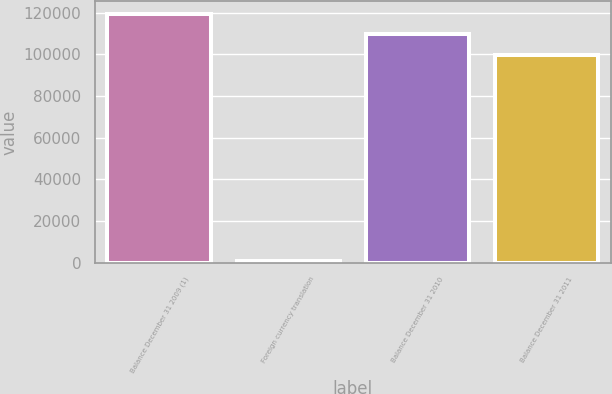<chart> <loc_0><loc_0><loc_500><loc_500><bar_chart><fcel>Balance December 31 2009 (1)<fcel>Foreign currency translation<fcel>Balance December 31 2010<fcel>Balance December 31 2011<nl><fcel>119640<fcel>927<fcel>109659<fcel>99677<nl></chart> 